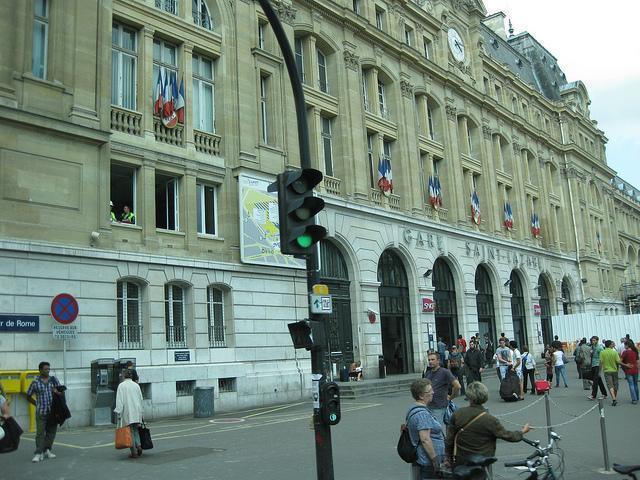How many traffic signals can be seen?
Give a very brief answer. 1. How many people are in the photo?
Give a very brief answer. 4. 